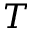Convert formula to latex. <formula><loc_0><loc_0><loc_500><loc_500>T</formula> 